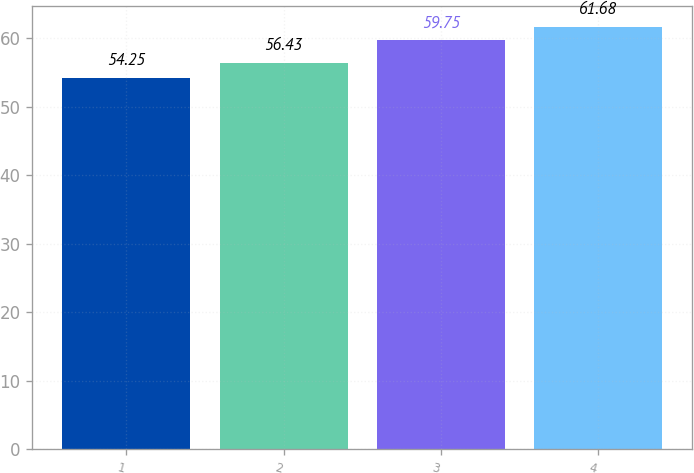<chart> <loc_0><loc_0><loc_500><loc_500><bar_chart><fcel>1<fcel>2<fcel>3<fcel>4<nl><fcel>54.25<fcel>56.43<fcel>59.75<fcel>61.68<nl></chart> 